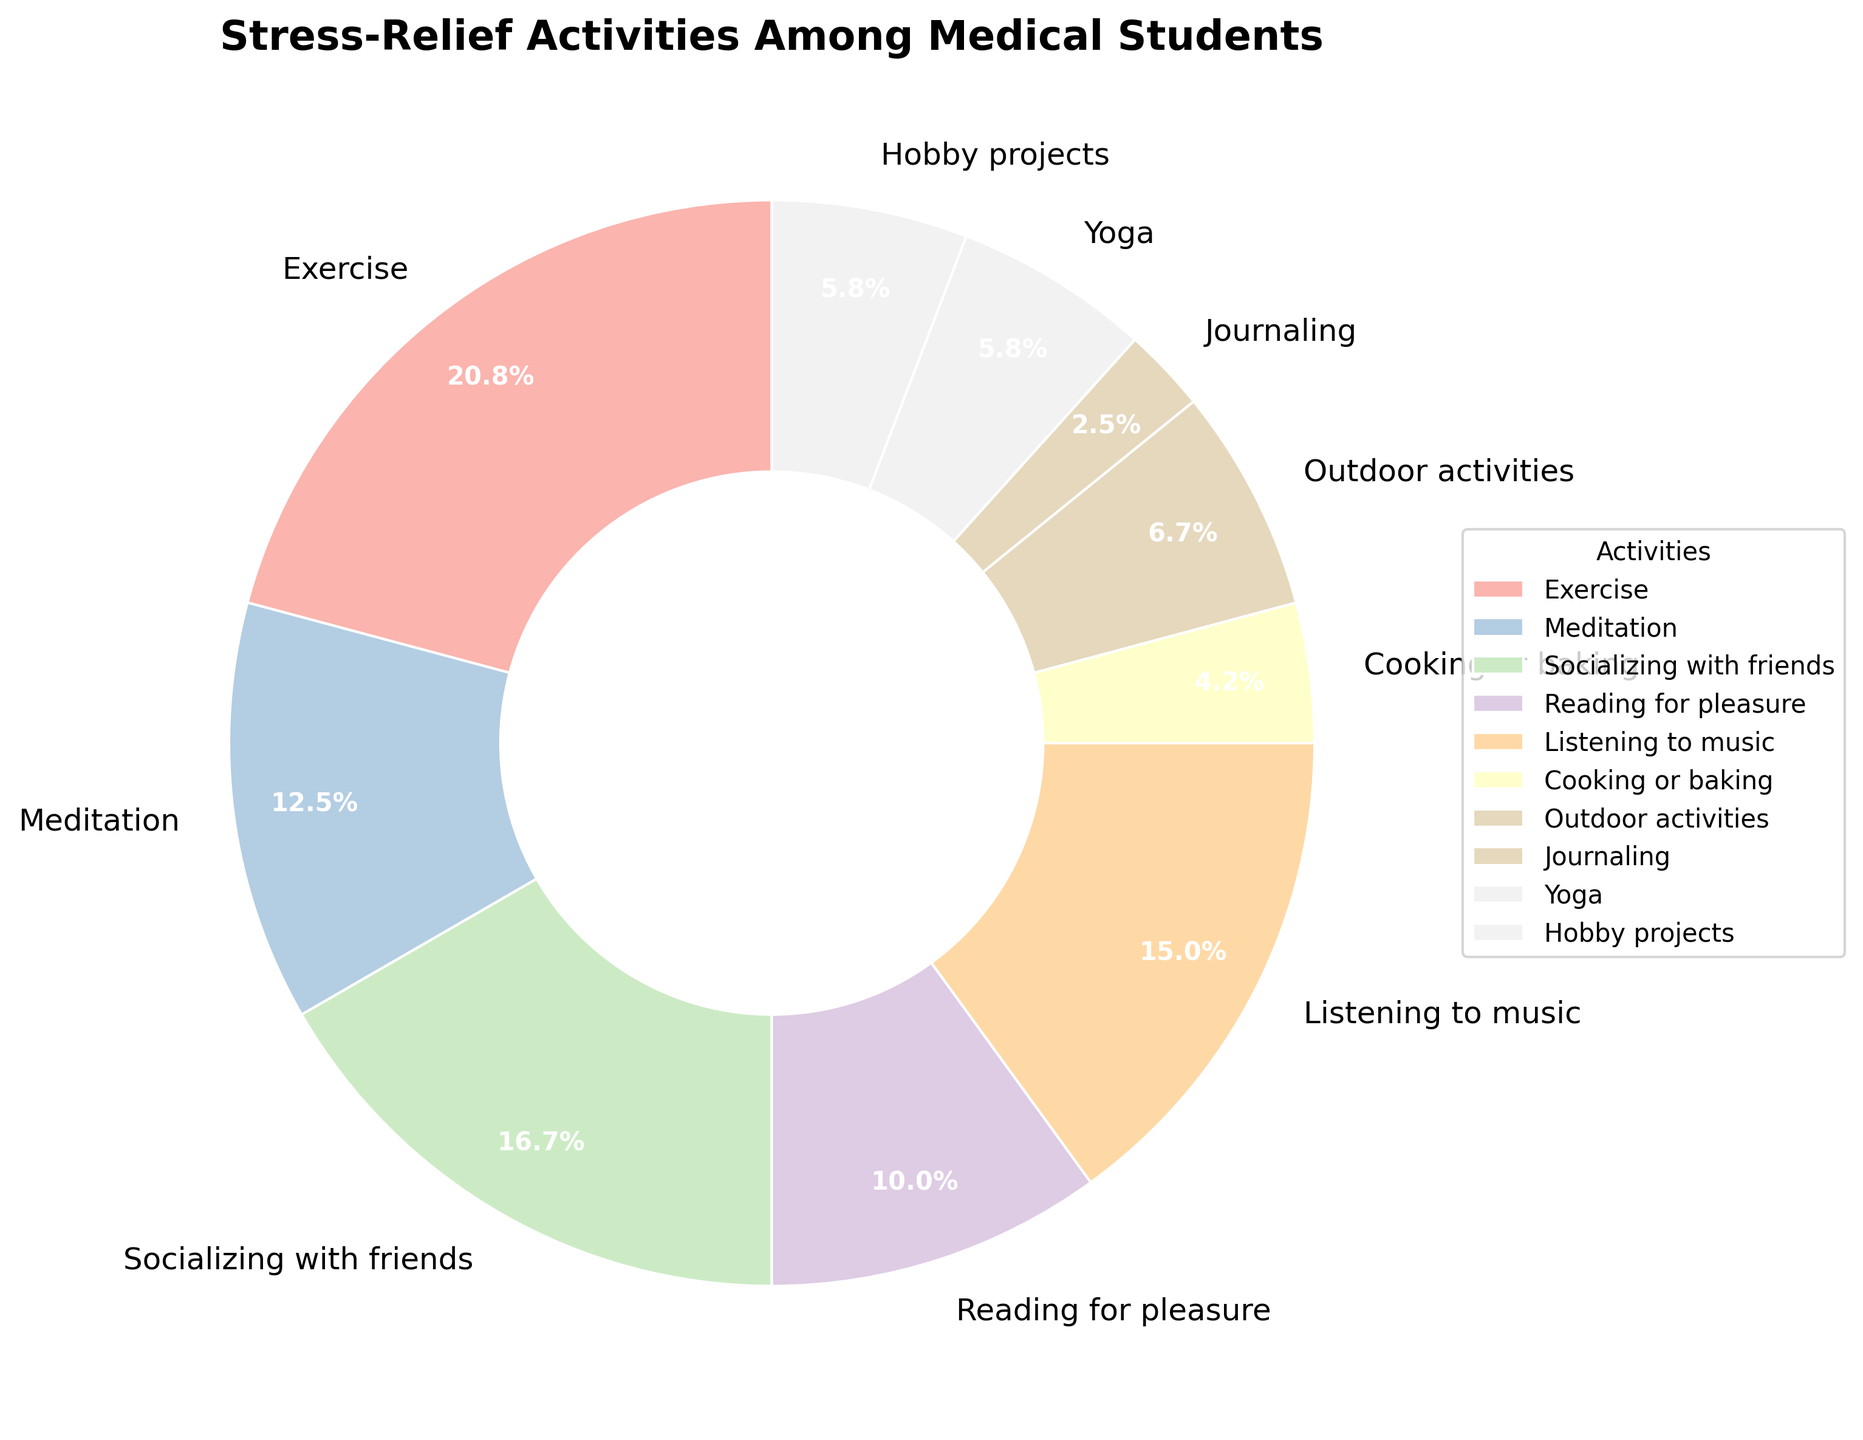What proportion of medical students prefer exercise for stress relief? The percentage for exercise is labeled on the pie chart.
Answer: 25% Which stress-relief activity has the smallest proportion among medical students? By looking at the chart, the smallest wedge corresponds to the activity labeled as journaling.
Answer: Journaling What is the total percentage of students who prefer outdoor activities, yoga, and hobby projects combined? Add the percentages for outdoor activities (8%), yoga (7%), and hobby projects (7%) from the chart. 8% + 7% + 7% = 22%
Answer: 22% How does the proportion of students who listen to music for stress relief compare to those who cook or bake? The chart shows 18% for listening to music and 5% for cooking or baking. 18% is greater than 5%.
Answer: Listening to music is 13% more than cooking or baking Which activity is more popular: meditation or reading for pleasure? By comparing the labeled percentages, 15% belongs to meditation and 12% to reading for pleasure.
Answer: Meditation What is the difference in percentage between the two most popular stress-relief activities? The two most popular activities are exercise (25%) and socializing with friends (20%). The difference is 25% - 20% = 5%
Answer: 5% If we combine the percentages of reading for pleasure and journaling, does it exceed socializing with friends? Reading for pleasure is 12% and journaling is 3%. Combined they make 12% + 3% = 15%, which is less than socializing with friends (20%).
Answer: No What percentage of students engage in either socializing with friends or listening to music for stress relief? Add the percentages for socializing with friends (20%) and listening to music (18%). 20% + 18% = 38%
Answer: 38% Which activities occupy an equal percentage of the pie chart? From the chart, yoga and hobby projects both have a percentage of 7%.
Answer: Yoga and hobby projects 